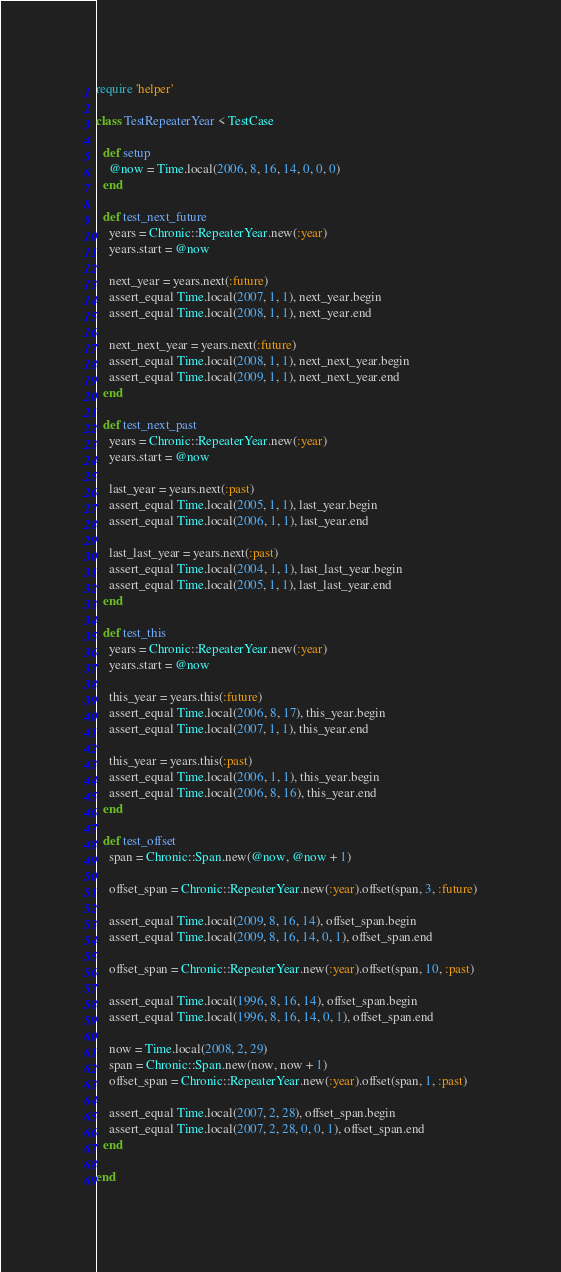<code> <loc_0><loc_0><loc_500><loc_500><_Ruby_>require 'helper'

class TestRepeaterYear < TestCase

  def setup
    @now = Time.local(2006, 8, 16, 14, 0, 0, 0)
  end

  def test_next_future
    years = Chronic::RepeaterYear.new(:year)
    years.start = @now

    next_year = years.next(:future)
    assert_equal Time.local(2007, 1, 1), next_year.begin
    assert_equal Time.local(2008, 1, 1), next_year.end

    next_next_year = years.next(:future)
    assert_equal Time.local(2008, 1, 1), next_next_year.begin
    assert_equal Time.local(2009, 1, 1), next_next_year.end
  end

  def test_next_past
    years = Chronic::RepeaterYear.new(:year)
    years.start = @now

    last_year = years.next(:past)
    assert_equal Time.local(2005, 1, 1), last_year.begin
    assert_equal Time.local(2006, 1, 1), last_year.end

    last_last_year = years.next(:past)
    assert_equal Time.local(2004, 1, 1), last_last_year.begin
    assert_equal Time.local(2005, 1, 1), last_last_year.end
  end

  def test_this
    years = Chronic::RepeaterYear.new(:year)
    years.start = @now

    this_year = years.this(:future)
    assert_equal Time.local(2006, 8, 17), this_year.begin
    assert_equal Time.local(2007, 1, 1), this_year.end

    this_year = years.this(:past)
    assert_equal Time.local(2006, 1, 1), this_year.begin
    assert_equal Time.local(2006, 8, 16), this_year.end
  end

  def test_offset
    span = Chronic::Span.new(@now, @now + 1)

    offset_span = Chronic::RepeaterYear.new(:year).offset(span, 3, :future)

    assert_equal Time.local(2009, 8, 16, 14), offset_span.begin
    assert_equal Time.local(2009, 8, 16, 14, 0, 1), offset_span.end

    offset_span = Chronic::RepeaterYear.new(:year).offset(span, 10, :past)

    assert_equal Time.local(1996, 8, 16, 14), offset_span.begin
    assert_equal Time.local(1996, 8, 16, 14, 0, 1), offset_span.end

    now = Time.local(2008, 2, 29)
    span = Chronic::Span.new(now, now + 1)
    offset_span = Chronic::RepeaterYear.new(:year).offset(span, 1, :past)

    assert_equal Time.local(2007, 2, 28), offset_span.begin
    assert_equal Time.local(2007, 2, 28, 0, 0, 1), offset_span.end
  end

end
</code> 